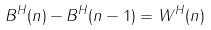<formula> <loc_0><loc_0><loc_500><loc_500>B ^ { H } ( n ) - B ^ { H } ( n - 1 ) = W ^ { H } ( n )</formula> 